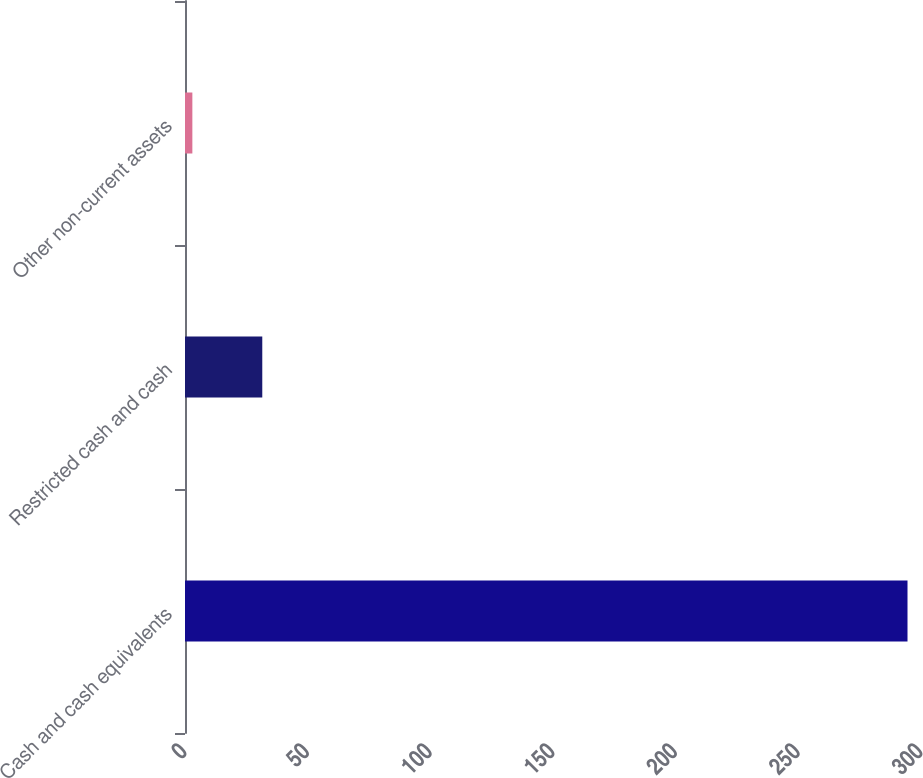Convert chart. <chart><loc_0><loc_0><loc_500><loc_500><bar_chart><fcel>Cash and cash equivalents<fcel>Restricted cash and cash<fcel>Other non-current assets<nl><fcel>294.5<fcel>31.5<fcel>3<nl></chart> 